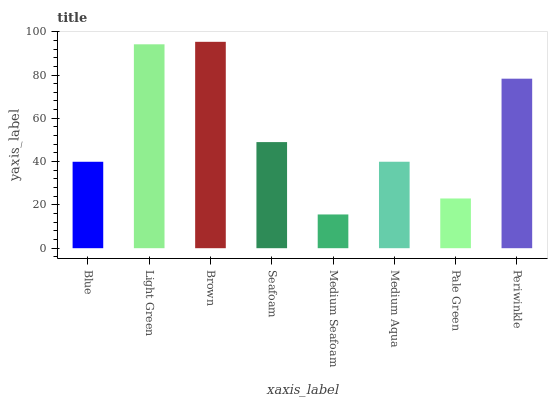Is Medium Seafoam the minimum?
Answer yes or no. Yes. Is Brown the maximum?
Answer yes or no. Yes. Is Light Green the minimum?
Answer yes or no. No. Is Light Green the maximum?
Answer yes or no. No. Is Light Green greater than Blue?
Answer yes or no. Yes. Is Blue less than Light Green?
Answer yes or no. Yes. Is Blue greater than Light Green?
Answer yes or no. No. Is Light Green less than Blue?
Answer yes or no. No. Is Seafoam the high median?
Answer yes or no. Yes. Is Medium Aqua the low median?
Answer yes or no. Yes. Is Periwinkle the high median?
Answer yes or no. No. Is Brown the low median?
Answer yes or no. No. 